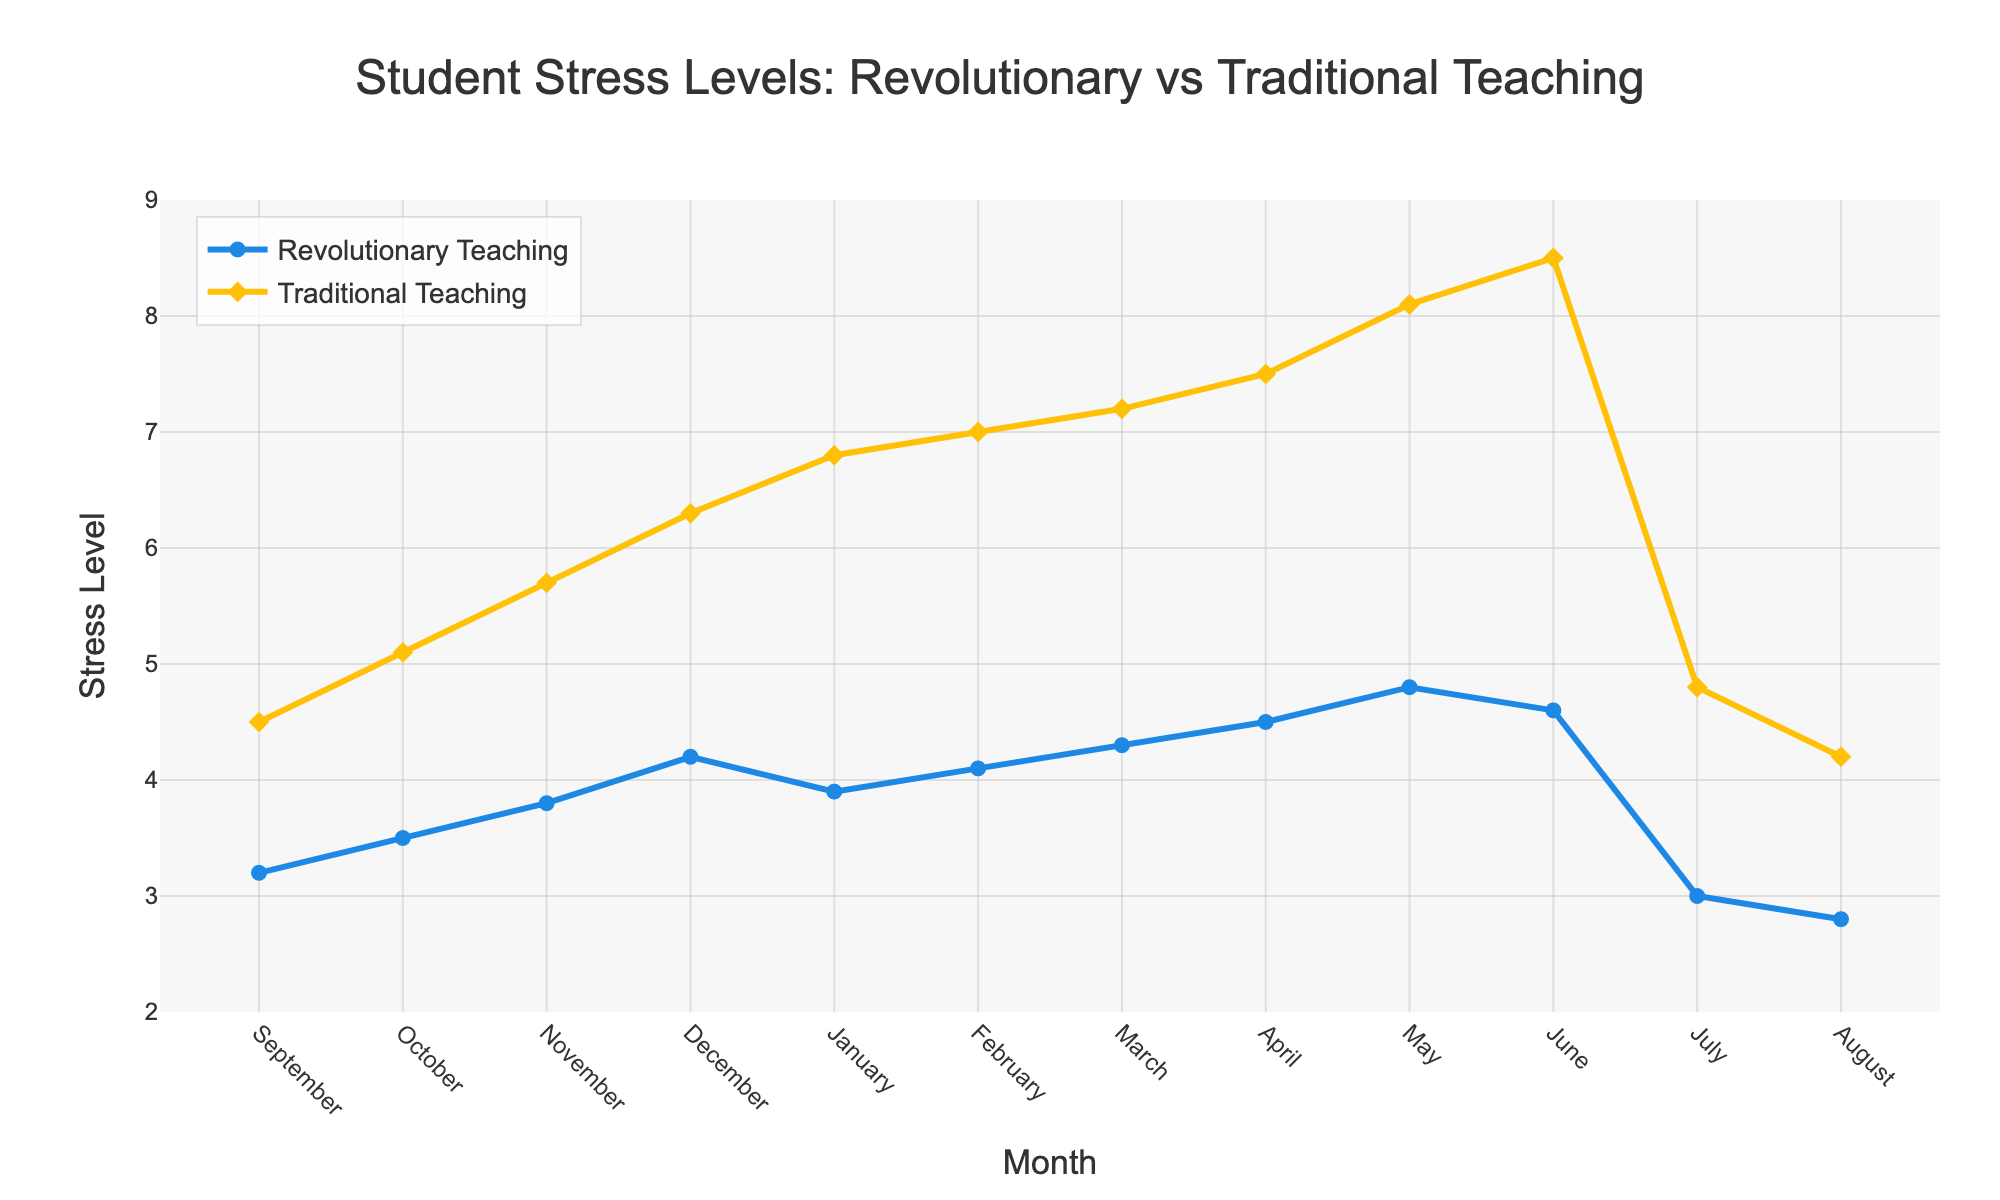What month shows the highest stress level for students with Traditional Teaching? Look at the 'Traditional Teaching' line and identify the peak value. The highest point on the yellow line is in June.
Answer: June How does the stress level in October compare between Revolutionary and Traditional Teaching? Compare the 'Revolutionary Teaching' value in October (3.5) to the 'Traditional Teaching' value in October (5.1).
Answer: Traditional Teaching is higher What is the difference in stress levels between January and July for Revolutionary Teaching? Look at the 'Revolutionary Teaching' line for January (3.9) and July (3.0). Calculate the difference: 3.9 - 3.0 = 0.9.
Answer: 0.9 In which month is the stress level the same for both teaching methods? Analyze both lines to find the intersection point. The stress levels are equal in August at 2.8.
Answer: August When does the stress level start to rise for both teaching methods after summer? Look at the end of the summer months (July, August). The stress levels start to rise in September.
Answer: September What is the average stress level for Revolutionary Teaching from September to December? Add the values from September (3.2), October (3.5), November (3.8), and December (4.2) and divide by 4: (3.2 + 3.5 + 3.8 + 4.2) / 4 = 3.675.
Answer: 3.675 By how much does the stress level increase from January to May for Traditional Teaching? Look at the 'Traditional Teaching' line for January (6.8) and May (8.1). Calculate the increase: 8.1 - 6.8 = 1.3.
Answer: 1.3 Which teaching method shows a lower stress level in May, and by how much? Compare the 'Revolutionary Teaching' value in May (4.8) to the 'Traditional Teaching' value in May (8.1). Calculate the difference: 8.1 - 4.8 = 3.3.
Answer: Revolutionary Teaching by 3.3 What is the trend in stress levels from March to June for Revolutionary Teaching? Observe the 'Revolutionary Teaching' line from March (4.3) to June (4.6). The trend is slightly increasing.
Answer: Slightly increasing 